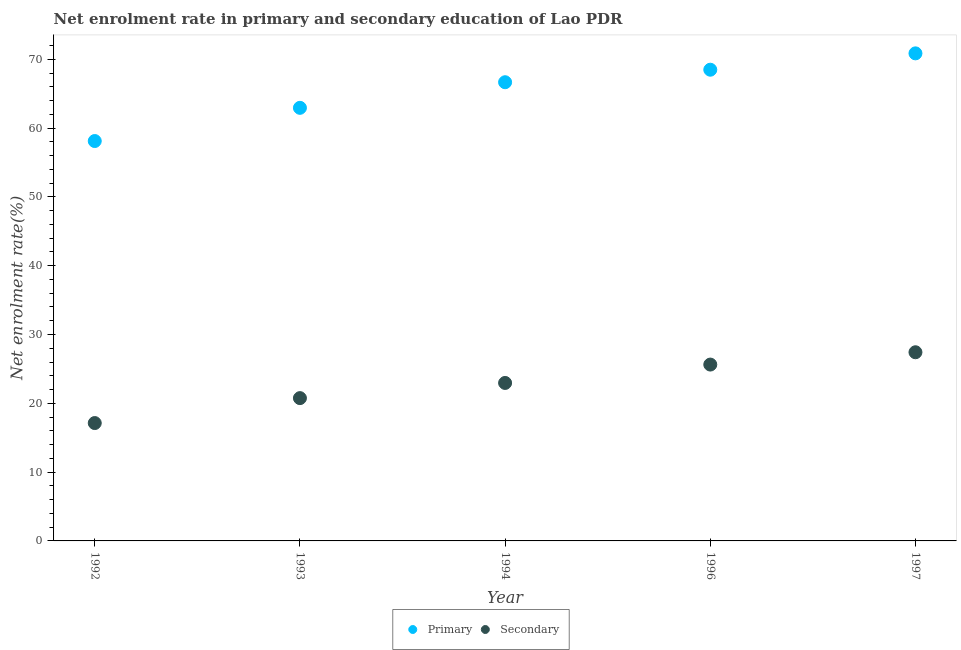What is the enrollment rate in primary education in 1997?
Make the answer very short. 70.86. Across all years, what is the maximum enrollment rate in secondary education?
Provide a short and direct response. 27.42. Across all years, what is the minimum enrollment rate in secondary education?
Provide a succinct answer. 17.13. In which year was the enrollment rate in primary education maximum?
Give a very brief answer. 1997. In which year was the enrollment rate in primary education minimum?
Offer a terse response. 1992. What is the total enrollment rate in secondary education in the graph?
Ensure brevity in your answer.  113.9. What is the difference between the enrollment rate in primary education in 1992 and that in 1996?
Make the answer very short. -10.37. What is the difference between the enrollment rate in secondary education in 1993 and the enrollment rate in primary education in 1996?
Make the answer very short. -47.73. What is the average enrollment rate in secondary education per year?
Keep it short and to the point. 22.78. In the year 1997, what is the difference between the enrollment rate in secondary education and enrollment rate in primary education?
Offer a very short reply. -43.44. What is the ratio of the enrollment rate in secondary education in 1993 to that in 1997?
Offer a very short reply. 0.76. What is the difference between the highest and the second highest enrollment rate in primary education?
Make the answer very short. 2.38. What is the difference between the highest and the lowest enrollment rate in secondary education?
Provide a succinct answer. 10.29. In how many years, is the enrollment rate in primary education greater than the average enrollment rate in primary education taken over all years?
Provide a short and direct response. 3. Is the sum of the enrollment rate in secondary education in 1994 and 1996 greater than the maximum enrollment rate in primary education across all years?
Ensure brevity in your answer.  No. Does the enrollment rate in secondary education monotonically increase over the years?
Your response must be concise. Yes. Is the enrollment rate in primary education strictly less than the enrollment rate in secondary education over the years?
Offer a terse response. No. How many dotlines are there?
Give a very brief answer. 2. How many years are there in the graph?
Your answer should be very brief. 5. Are the values on the major ticks of Y-axis written in scientific E-notation?
Offer a terse response. No. Where does the legend appear in the graph?
Your answer should be compact. Bottom center. What is the title of the graph?
Your answer should be very brief. Net enrolment rate in primary and secondary education of Lao PDR. Does "Sanitation services" appear as one of the legend labels in the graph?
Make the answer very short. No. What is the label or title of the Y-axis?
Provide a succinct answer. Net enrolment rate(%). What is the Net enrolment rate(%) in Primary in 1992?
Provide a short and direct response. 58.12. What is the Net enrolment rate(%) in Secondary in 1992?
Offer a very short reply. 17.13. What is the Net enrolment rate(%) in Primary in 1993?
Your response must be concise. 62.95. What is the Net enrolment rate(%) in Secondary in 1993?
Your response must be concise. 20.76. What is the Net enrolment rate(%) in Primary in 1994?
Your response must be concise. 66.67. What is the Net enrolment rate(%) of Secondary in 1994?
Offer a terse response. 22.96. What is the Net enrolment rate(%) of Primary in 1996?
Your answer should be compact. 68.49. What is the Net enrolment rate(%) of Secondary in 1996?
Provide a succinct answer. 25.63. What is the Net enrolment rate(%) in Primary in 1997?
Make the answer very short. 70.86. What is the Net enrolment rate(%) in Secondary in 1997?
Give a very brief answer. 27.42. Across all years, what is the maximum Net enrolment rate(%) of Primary?
Ensure brevity in your answer.  70.86. Across all years, what is the maximum Net enrolment rate(%) in Secondary?
Offer a very short reply. 27.42. Across all years, what is the minimum Net enrolment rate(%) of Primary?
Make the answer very short. 58.12. Across all years, what is the minimum Net enrolment rate(%) of Secondary?
Provide a succinct answer. 17.13. What is the total Net enrolment rate(%) in Primary in the graph?
Offer a terse response. 327.09. What is the total Net enrolment rate(%) of Secondary in the graph?
Ensure brevity in your answer.  113.9. What is the difference between the Net enrolment rate(%) in Primary in 1992 and that in 1993?
Your answer should be very brief. -4.83. What is the difference between the Net enrolment rate(%) of Secondary in 1992 and that in 1993?
Provide a succinct answer. -3.63. What is the difference between the Net enrolment rate(%) of Primary in 1992 and that in 1994?
Your answer should be very brief. -8.55. What is the difference between the Net enrolment rate(%) in Secondary in 1992 and that in 1994?
Give a very brief answer. -5.83. What is the difference between the Net enrolment rate(%) of Primary in 1992 and that in 1996?
Ensure brevity in your answer.  -10.37. What is the difference between the Net enrolment rate(%) in Secondary in 1992 and that in 1996?
Ensure brevity in your answer.  -8.5. What is the difference between the Net enrolment rate(%) of Primary in 1992 and that in 1997?
Your answer should be very brief. -12.74. What is the difference between the Net enrolment rate(%) in Secondary in 1992 and that in 1997?
Offer a very short reply. -10.29. What is the difference between the Net enrolment rate(%) of Primary in 1993 and that in 1994?
Ensure brevity in your answer.  -3.72. What is the difference between the Net enrolment rate(%) in Secondary in 1993 and that in 1994?
Keep it short and to the point. -2.2. What is the difference between the Net enrolment rate(%) in Primary in 1993 and that in 1996?
Ensure brevity in your answer.  -5.54. What is the difference between the Net enrolment rate(%) of Secondary in 1993 and that in 1996?
Your response must be concise. -4.88. What is the difference between the Net enrolment rate(%) of Primary in 1993 and that in 1997?
Offer a terse response. -7.92. What is the difference between the Net enrolment rate(%) of Secondary in 1993 and that in 1997?
Your answer should be compact. -6.67. What is the difference between the Net enrolment rate(%) of Primary in 1994 and that in 1996?
Ensure brevity in your answer.  -1.82. What is the difference between the Net enrolment rate(%) in Secondary in 1994 and that in 1996?
Make the answer very short. -2.67. What is the difference between the Net enrolment rate(%) in Primary in 1994 and that in 1997?
Offer a terse response. -4.2. What is the difference between the Net enrolment rate(%) of Secondary in 1994 and that in 1997?
Provide a succinct answer. -4.46. What is the difference between the Net enrolment rate(%) of Primary in 1996 and that in 1997?
Give a very brief answer. -2.38. What is the difference between the Net enrolment rate(%) of Secondary in 1996 and that in 1997?
Keep it short and to the point. -1.79. What is the difference between the Net enrolment rate(%) of Primary in 1992 and the Net enrolment rate(%) of Secondary in 1993?
Make the answer very short. 37.37. What is the difference between the Net enrolment rate(%) of Primary in 1992 and the Net enrolment rate(%) of Secondary in 1994?
Keep it short and to the point. 35.16. What is the difference between the Net enrolment rate(%) of Primary in 1992 and the Net enrolment rate(%) of Secondary in 1996?
Provide a succinct answer. 32.49. What is the difference between the Net enrolment rate(%) of Primary in 1992 and the Net enrolment rate(%) of Secondary in 1997?
Ensure brevity in your answer.  30.7. What is the difference between the Net enrolment rate(%) in Primary in 1993 and the Net enrolment rate(%) in Secondary in 1994?
Provide a short and direct response. 39.99. What is the difference between the Net enrolment rate(%) of Primary in 1993 and the Net enrolment rate(%) of Secondary in 1996?
Offer a terse response. 37.32. What is the difference between the Net enrolment rate(%) in Primary in 1993 and the Net enrolment rate(%) in Secondary in 1997?
Make the answer very short. 35.53. What is the difference between the Net enrolment rate(%) of Primary in 1994 and the Net enrolment rate(%) of Secondary in 1996?
Your answer should be compact. 41.04. What is the difference between the Net enrolment rate(%) of Primary in 1994 and the Net enrolment rate(%) of Secondary in 1997?
Provide a succinct answer. 39.25. What is the difference between the Net enrolment rate(%) in Primary in 1996 and the Net enrolment rate(%) in Secondary in 1997?
Make the answer very short. 41.07. What is the average Net enrolment rate(%) in Primary per year?
Your answer should be compact. 65.42. What is the average Net enrolment rate(%) in Secondary per year?
Provide a succinct answer. 22.78. In the year 1992, what is the difference between the Net enrolment rate(%) of Primary and Net enrolment rate(%) of Secondary?
Give a very brief answer. 40.99. In the year 1993, what is the difference between the Net enrolment rate(%) of Primary and Net enrolment rate(%) of Secondary?
Ensure brevity in your answer.  42.19. In the year 1994, what is the difference between the Net enrolment rate(%) of Primary and Net enrolment rate(%) of Secondary?
Provide a short and direct response. 43.71. In the year 1996, what is the difference between the Net enrolment rate(%) of Primary and Net enrolment rate(%) of Secondary?
Offer a very short reply. 42.86. In the year 1997, what is the difference between the Net enrolment rate(%) in Primary and Net enrolment rate(%) in Secondary?
Offer a very short reply. 43.44. What is the ratio of the Net enrolment rate(%) in Primary in 1992 to that in 1993?
Your response must be concise. 0.92. What is the ratio of the Net enrolment rate(%) of Secondary in 1992 to that in 1993?
Your response must be concise. 0.83. What is the ratio of the Net enrolment rate(%) in Primary in 1992 to that in 1994?
Give a very brief answer. 0.87. What is the ratio of the Net enrolment rate(%) in Secondary in 1992 to that in 1994?
Keep it short and to the point. 0.75. What is the ratio of the Net enrolment rate(%) of Primary in 1992 to that in 1996?
Ensure brevity in your answer.  0.85. What is the ratio of the Net enrolment rate(%) in Secondary in 1992 to that in 1996?
Your answer should be very brief. 0.67. What is the ratio of the Net enrolment rate(%) in Primary in 1992 to that in 1997?
Provide a short and direct response. 0.82. What is the ratio of the Net enrolment rate(%) in Secondary in 1992 to that in 1997?
Keep it short and to the point. 0.62. What is the ratio of the Net enrolment rate(%) of Primary in 1993 to that in 1994?
Give a very brief answer. 0.94. What is the ratio of the Net enrolment rate(%) in Secondary in 1993 to that in 1994?
Offer a very short reply. 0.9. What is the ratio of the Net enrolment rate(%) in Primary in 1993 to that in 1996?
Provide a succinct answer. 0.92. What is the ratio of the Net enrolment rate(%) in Secondary in 1993 to that in 1996?
Ensure brevity in your answer.  0.81. What is the ratio of the Net enrolment rate(%) in Primary in 1993 to that in 1997?
Provide a short and direct response. 0.89. What is the ratio of the Net enrolment rate(%) of Secondary in 1993 to that in 1997?
Your answer should be very brief. 0.76. What is the ratio of the Net enrolment rate(%) in Primary in 1994 to that in 1996?
Make the answer very short. 0.97. What is the ratio of the Net enrolment rate(%) of Secondary in 1994 to that in 1996?
Your response must be concise. 0.9. What is the ratio of the Net enrolment rate(%) of Primary in 1994 to that in 1997?
Make the answer very short. 0.94. What is the ratio of the Net enrolment rate(%) in Secondary in 1994 to that in 1997?
Your answer should be compact. 0.84. What is the ratio of the Net enrolment rate(%) of Primary in 1996 to that in 1997?
Make the answer very short. 0.97. What is the ratio of the Net enrolment rate(%) of Secondary in 1996 to that in 1997?
Give a very brief answer. 0.93. What is the difference between the highest and the second highest Net enrolment rate(%) of Primary?
Offer a very short reply. 2.38. What is the difference between the highest and the second highest Net enrolment rate(%) in Secondary?
Offer a terse response. 1.79. What is the difference between the highest and the lowest Net enrolment rate(%) of Primary?
Your response must be concise. 12.74. What is the difference between the highest and the lowest Net enrolment rate(%) in Secondary?
Ensure brevity in your answer.  10.29. 